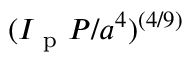<formula> <loc_0><loc_0><loc_500><loc_500>( I _ { p } P / a ^ { 4 } ) ^ { ( 4 / 9 ) }</formula> 